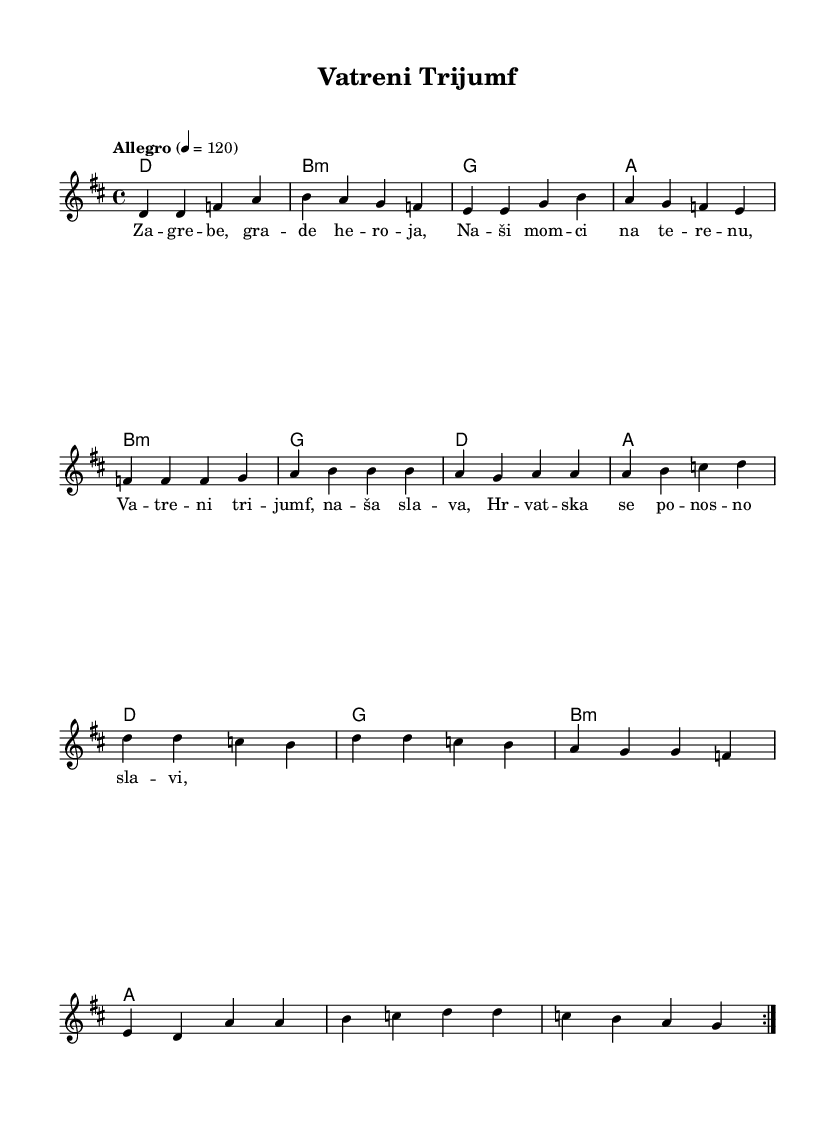What is the key signature of this music? The key signature indicates that there are two sharps, which corresponds to the key of D major.
Answer: D major What is the time signature of the piece? The time signature shown at the beginning of the score is 4/4, meaning there are four beats in each measure.
Answer: 4/4 What is the tempo marking of the piece? The tempo marking states "Allegro" with a beat of 120, indicating the piece should be played fast and lively.
Answer: Allegro, 120 How many verses are there in the song structure? The verses are repeated twice in the score, as indicated by the "repeat volta 2" instruction before the verse.
Answer: 2 What is the main theme celebrated in the chorus lyrics? The chorus lyrics celebrate the national sports victories of Croatia, specifically mentioning "Vatreni trijumf" which translates to "Fiery Triumph".
Answer: Vatreni trijumf What is the chord progression used in the verse? The chord progression in the verse is a series of four chords: D, B minor, G, and A, as indicated in the harmony section.
Answer: D, B minor, G, A How does the pre-chorus differ from the verse musically? The pre-chorus introduces a different melody and rhythm, providing a build-up to the chorus, contrasting with the melody of the verse.
Answer: Different melody 